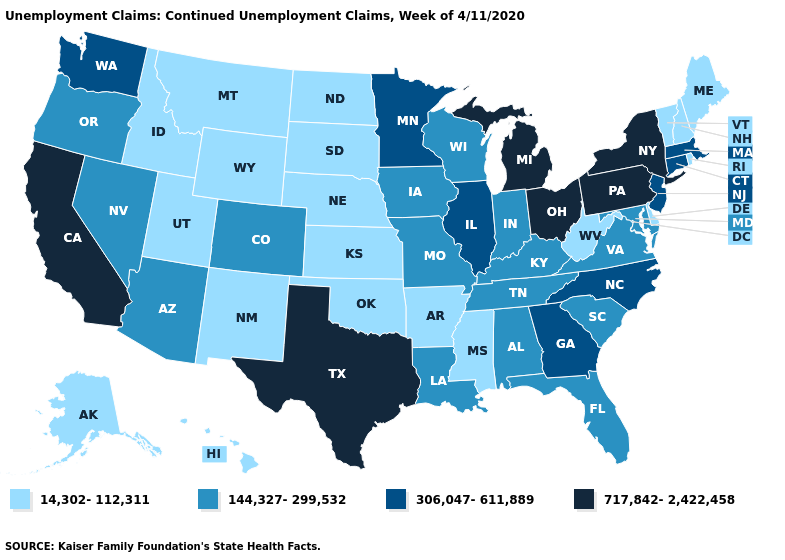What is the lowest value in states that border Vermont?
Give a very brief answer. 14,302-112,311. Which states have the lowest value in the USA?
Short answer required. Alaska, Arkansas, Delaware, Hawaii, Idaho, Kansas, Maine, Mississippi, Montana, Nebraska, New Hampshire, New Mexico, North Dakota, Oklahoma, Rhode Island, South Dakota, Utah, Vermont, West Virginia, Wyoming. Name the states that have a value in the range 14,302-112,311?
Concise answer only. Alaska, Arkansas, Delaware, Hawaii, Idaho, Kansas, Maine, Mississippi, Montana, Nebraska, New Hampshire, New Mexico, North Dakota, Oklahoma, Rhode Island, South Dakota, Utah, Vermont, West Virginia, Wyoming. Name the states that have a value in the range 717,842-2,422,458?
Give a very brief answer. California, Michigan, New York, Ohio, Pennsylvania, Texas. Name the states that have a value in the range 717,842-2,422,458?
Short answer required. California, Michigan, New York, Ohio, Pennsylvania, Texas. What is the lowest value in the South?
Concise answer only. 14,302-112,311. Does Massachusetts have a lower value than Texas?
Answer briefly. Yes. What is the lowest value in the USA?
Write a very short answer. 14,302-112,311. Does Florida have the lowest value in the USA?
Answer briefly. No. Among the states that border Alabama , which have the highest value?
Keep it brief. Georgia. What is the highest value in the USA?
Be succinct. 717,842-2,422,458. Which states have the highest value in the USA?
Concise answer only. California, Michigan, New York, Ohio, Pennsylvania, Texas. Name the states that have a value in the range 14,302-112,311?
Be succinct. Alaska, Arkansas, Delaware, Hawaii, Idaho, Kansas, Maine, Mississippi, Montana, Nebraska, New Hampshire, New Mexico, North Dakota, Oklahoma, Rhode Island, South Dakota, Utah, Vermont, West Virginia, Wyoming. Does the map have missing data?
Keep it brief. No. Does the map have missing data?
Short answer required. No. 